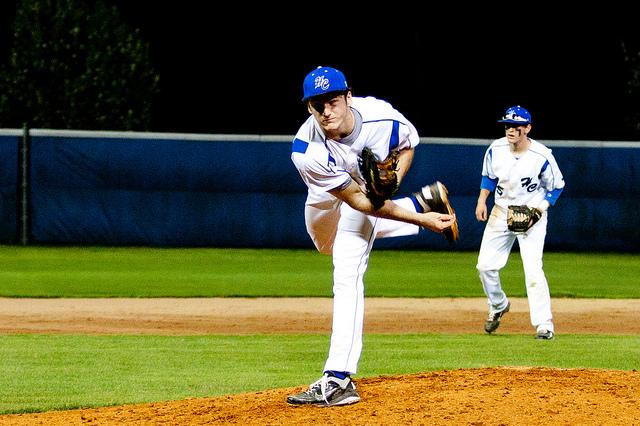Why does the man stand on one leg?

Choices:
A) running bases
B) pitching ball
C) stork pose
D) yoga move pitching ball 